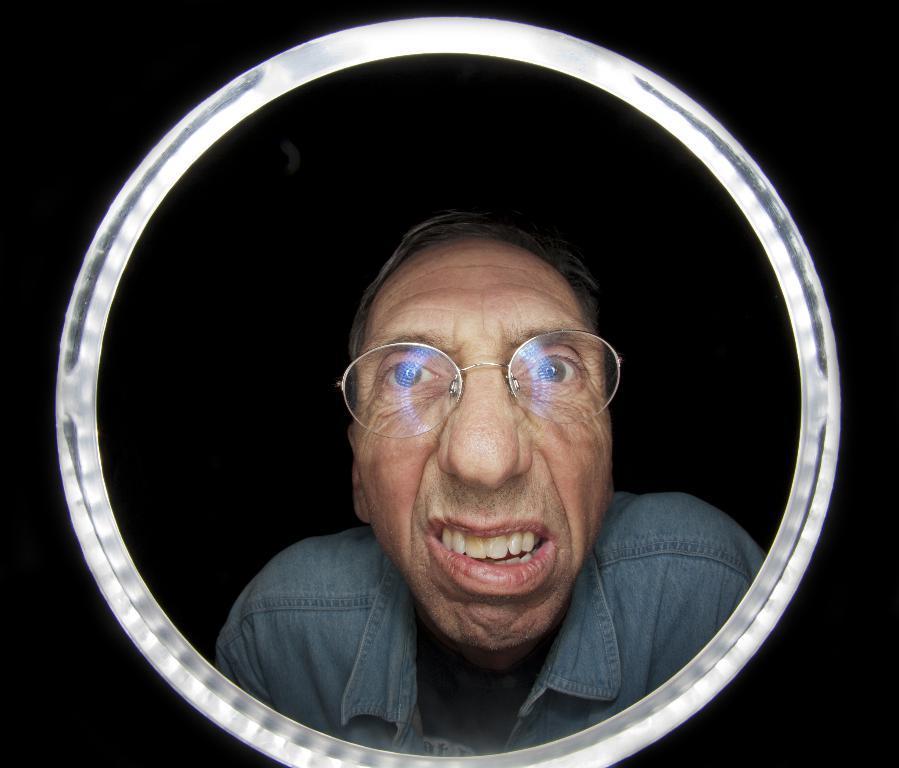Describe this image in one or two sentences. In this image we can see a reflection of a person in the mirror, and the background is blurred. 